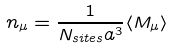Convert formula to latex. <formula><loc_0><loc_0><loc_500><loc_500>n _ { \mu } = \frac { 1 } { N _ { s i t e s } a ^ { 3 } } \langle M _ { \mu } \rangle</formula> 